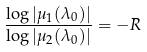<formula> <loc_0><loc_0><loc_500><loc_500>\frac { \log | \mu _ { 1 } ( \lambda _ { 0 } ) | } { \log | \mu _ { 2 } ( \lambda _ { 0 } ) | } = - R</formula> 